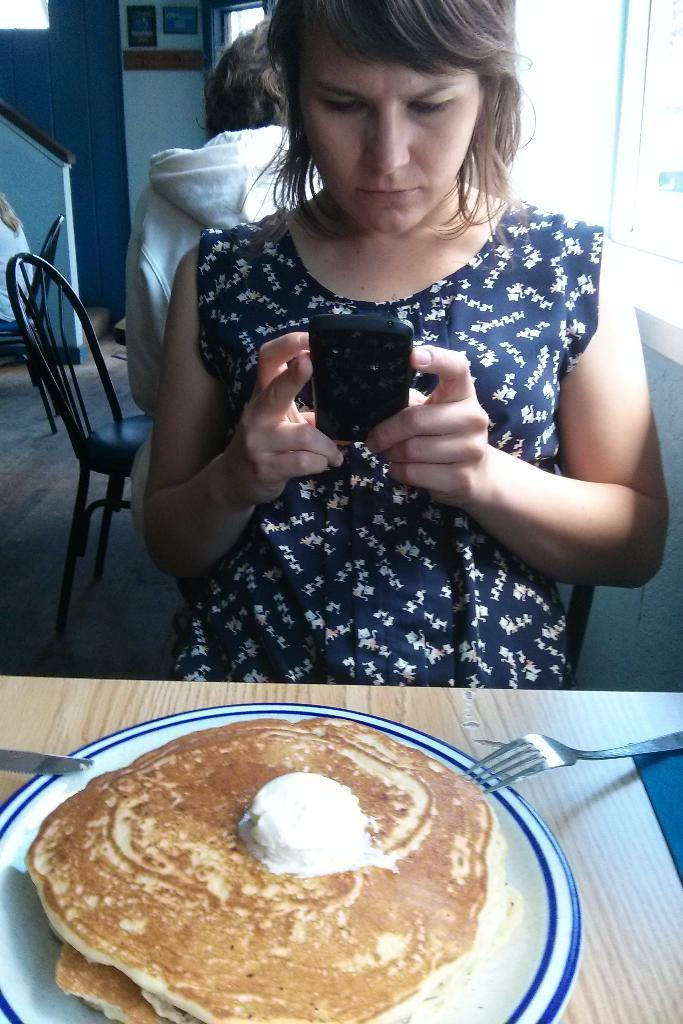What is on the plate that is visible in the image? There is food on a plate in the image. Where is the plate located in the image? The plate is on a table in the image. What utensils are present on the table? There is a fork and knives on the table. Who is seated in front of the table in the image? A lady is seated on a chair in front of the table. What is the lady looking at in the image? The lady is looking at a mobile in the image. What type of ink is being used to write on the bread in the image? There is no ink or bread present in the image; it features food on a plate, utensils, a lady, and a mobile. 